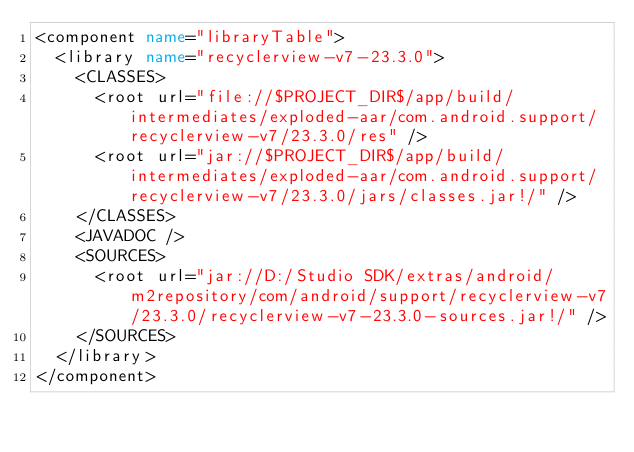<code> <loc_0><loc_0><loc_500><loc_500><_XML_><component name="libraryTable">
  <library name="recyclerview-v7-23.3.0">
    <CLASSES>
      <root url="file://$PROJECT_DIR$/app/build/intermediates/exploded-aar/com.android.support/recyclerview-v7/23.3.0/res" />
      <root url="jar://$PROJECT_DIR$/app/build/intermediates/exploded-aar/com.android.support/recyclerview-v7/23.3.0/jars/classes.jar!/" />
    </CLASSES>
    <JAVADOC />
    <SOURCES>
      <root url="jar://D:/Studio SDK/extras/android/m2repository/com/android/support/recyclerview-v7/23.3.0/recyclerview-v7-23.3.0-sources.jar!/" />
    </SOURCES>
  </library>
</component></code> 